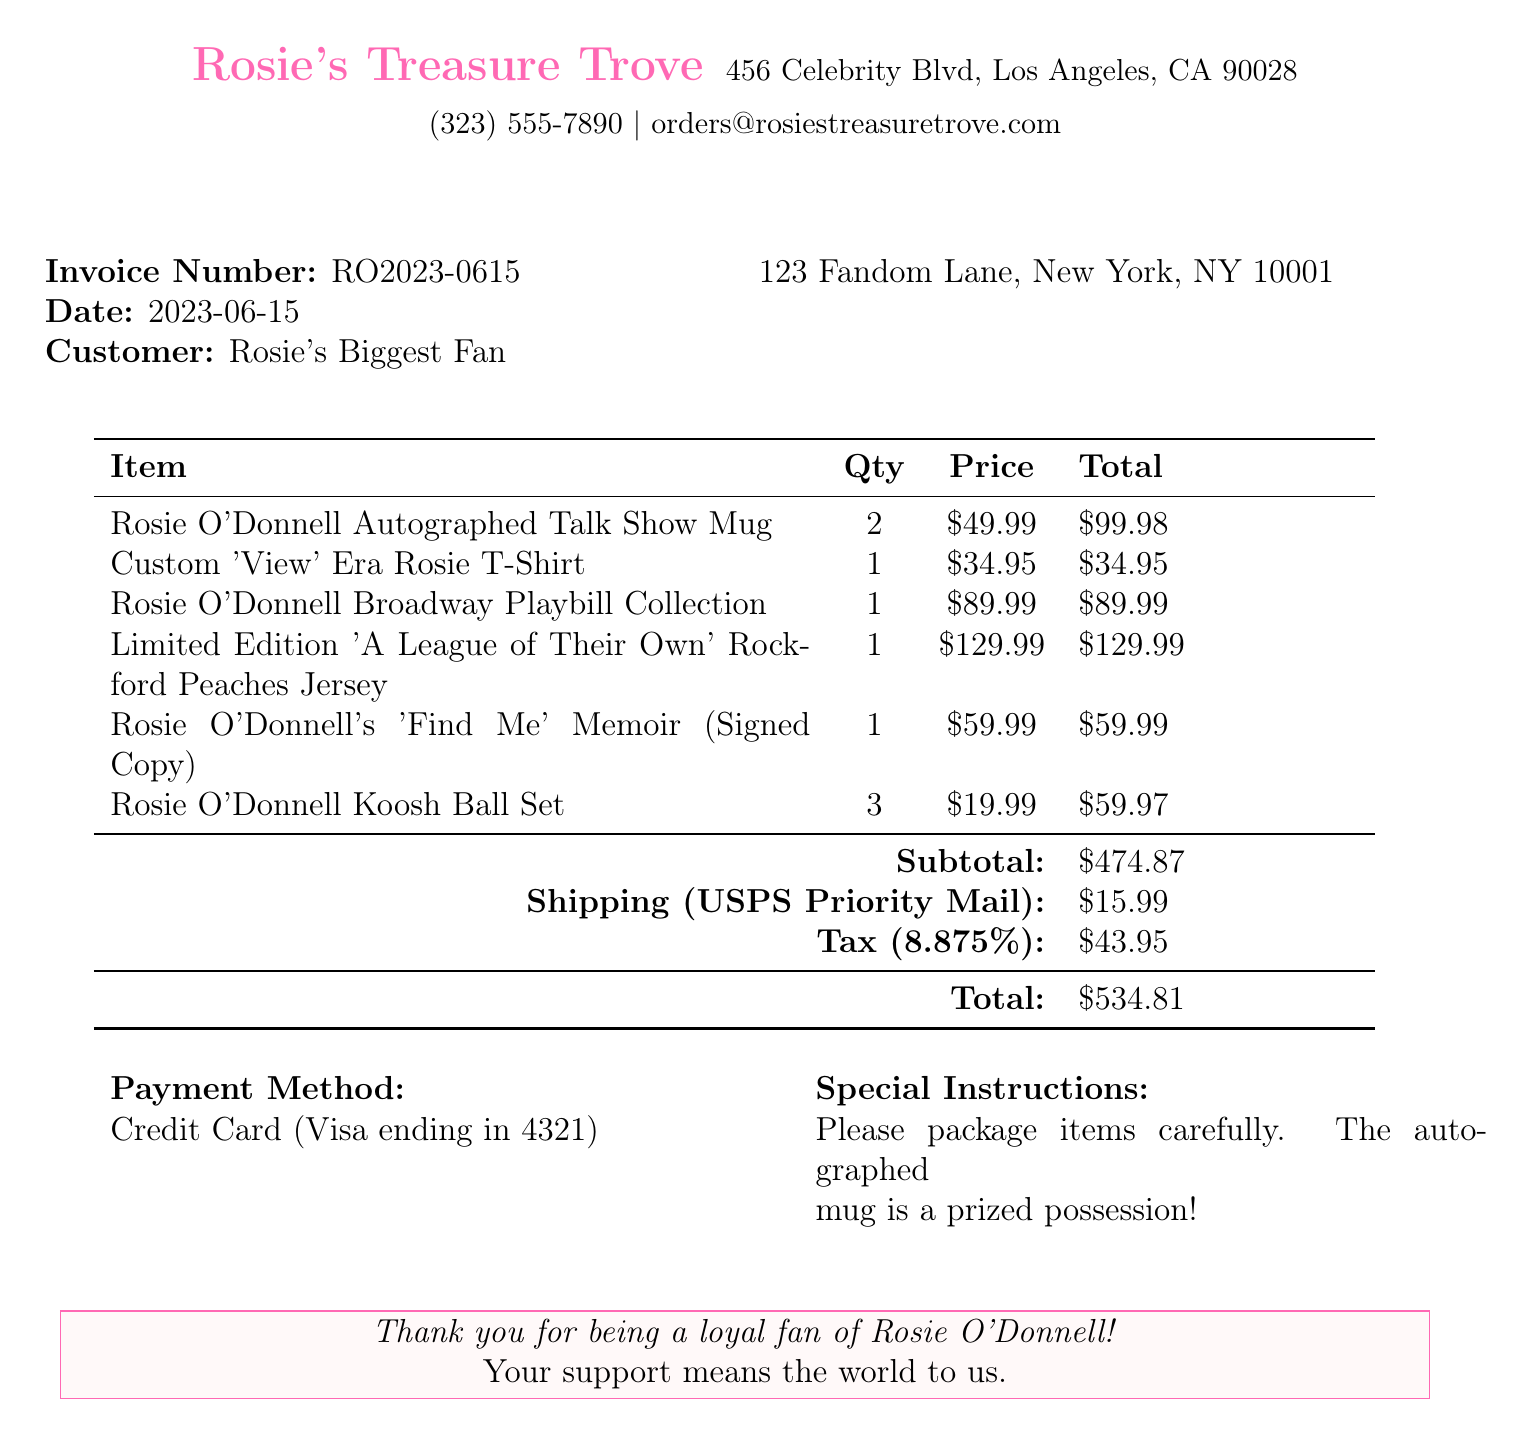what is the invoice number? The invoice number is provided at the beginning of the document, identifying the transaction.
Answer: RO2023-0615 who is the customer? The customer's name is given in the document to specify who made the purchase.
Answer: Rosie's Biggest Fan what is the date of the invoice? The date is listed to indicate when the transaction took place.
Answer: 2023-06-15 how many items are in total? To find the total items, we sum the quantities listed for all merchandise.
Answer: 8 what is the shipping cost? The shipping cost is detailed to show the expense of delivery.
Answer: $15.99 which payment method was used? The document specifies the payment method to clarify how the transaction was processed.
Answer: Credit Card (Visa ending in 4321) what is the total order amount? The total order amount stated includes the subtotal, shipping, and tax combined.
Answer: $534.81 what specific instructions were included with the order? The special instructions are provided to give guidance on handling the package.
Answer: Please package items carefully. The autographed mug is a prized possession! what is the name of the seller? The seller's name is found at the top of the document, providing details about the company.
Answer: Rosie's Treasure Trove 